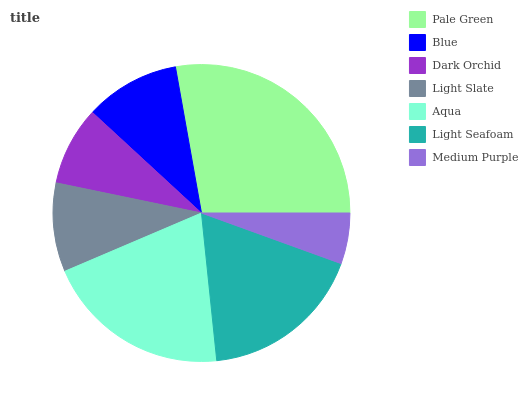Is Medium Purple the minimum?
Answer yes or no. Yes. Is Pale Green the maximum?
Answer yes or no. Yes. Is Blue the minimum?
Answer yes or no. No. Is Blue the maximum?
Answer yes or no. No. Is Pale Green greater than Blue?
Answer yes or no. Yes. Is Blue less than Pale Green?
Answer yes or no. Yes. Is Blue greater than Pale Green?
Answer yes or no. No. Is Pale Green less than Blue?
Answer yes or no. No. Is Blue the high median?
Answer yes or no. Yes. Is Blue the low median?
Answer yes or no. Yes. Is Dark Orchid the high median?
Answer yes or no. No. Is Pale Green the low median?
Answer yes or no. No. 